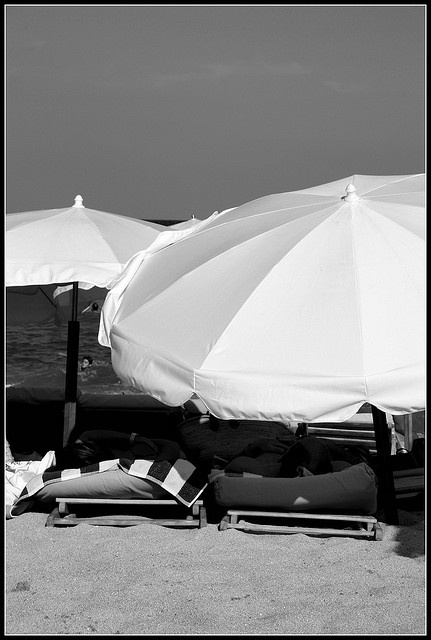Describe the objects in this image and their specific colors. I can see umbrella in black, lightgray, darkgray, and gray tones, umbrella in black, lightgray, darkgray, and gray tones, and people in black and gray tones in this image. 